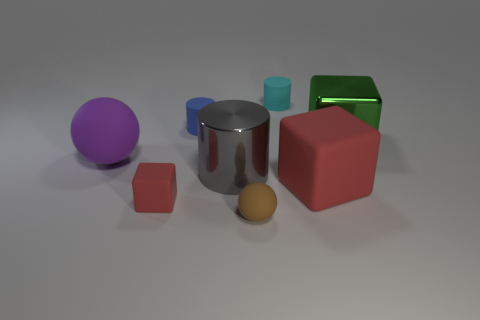Add 2 large purple matte things. How many objects exist? 10 Subtract all cylinders. How many objects are left? 5 Subtract all big purple rubber objects. Subtract all tiny brown spheres. How many objects are left? 6 Add 8 cyan cylinders. How many cyan cylinders are left? 9 Add 4 tiny gray objects. How many tiny gray objects exist? 4 Subtract 0 yellow balls. How many objects are left? 8 